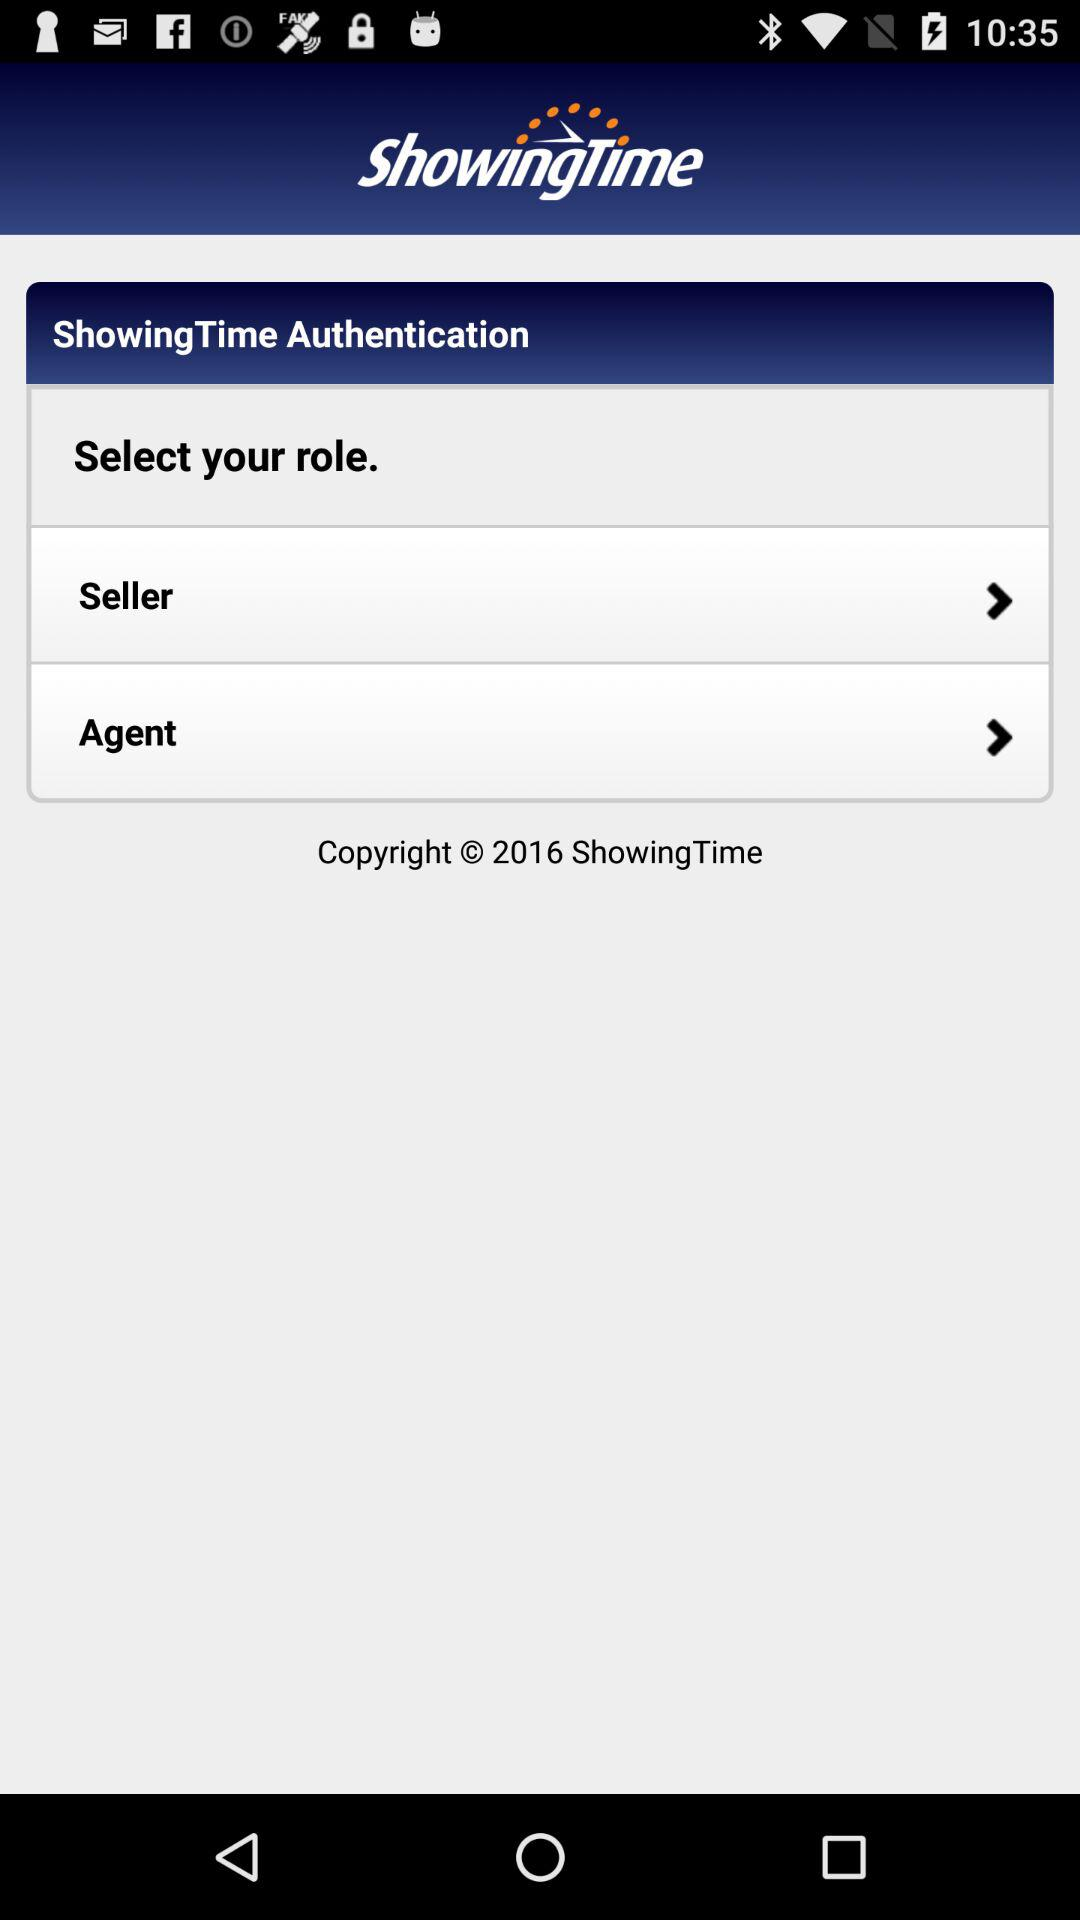What is the name of the application? The name of the application is "ShowingTime". 